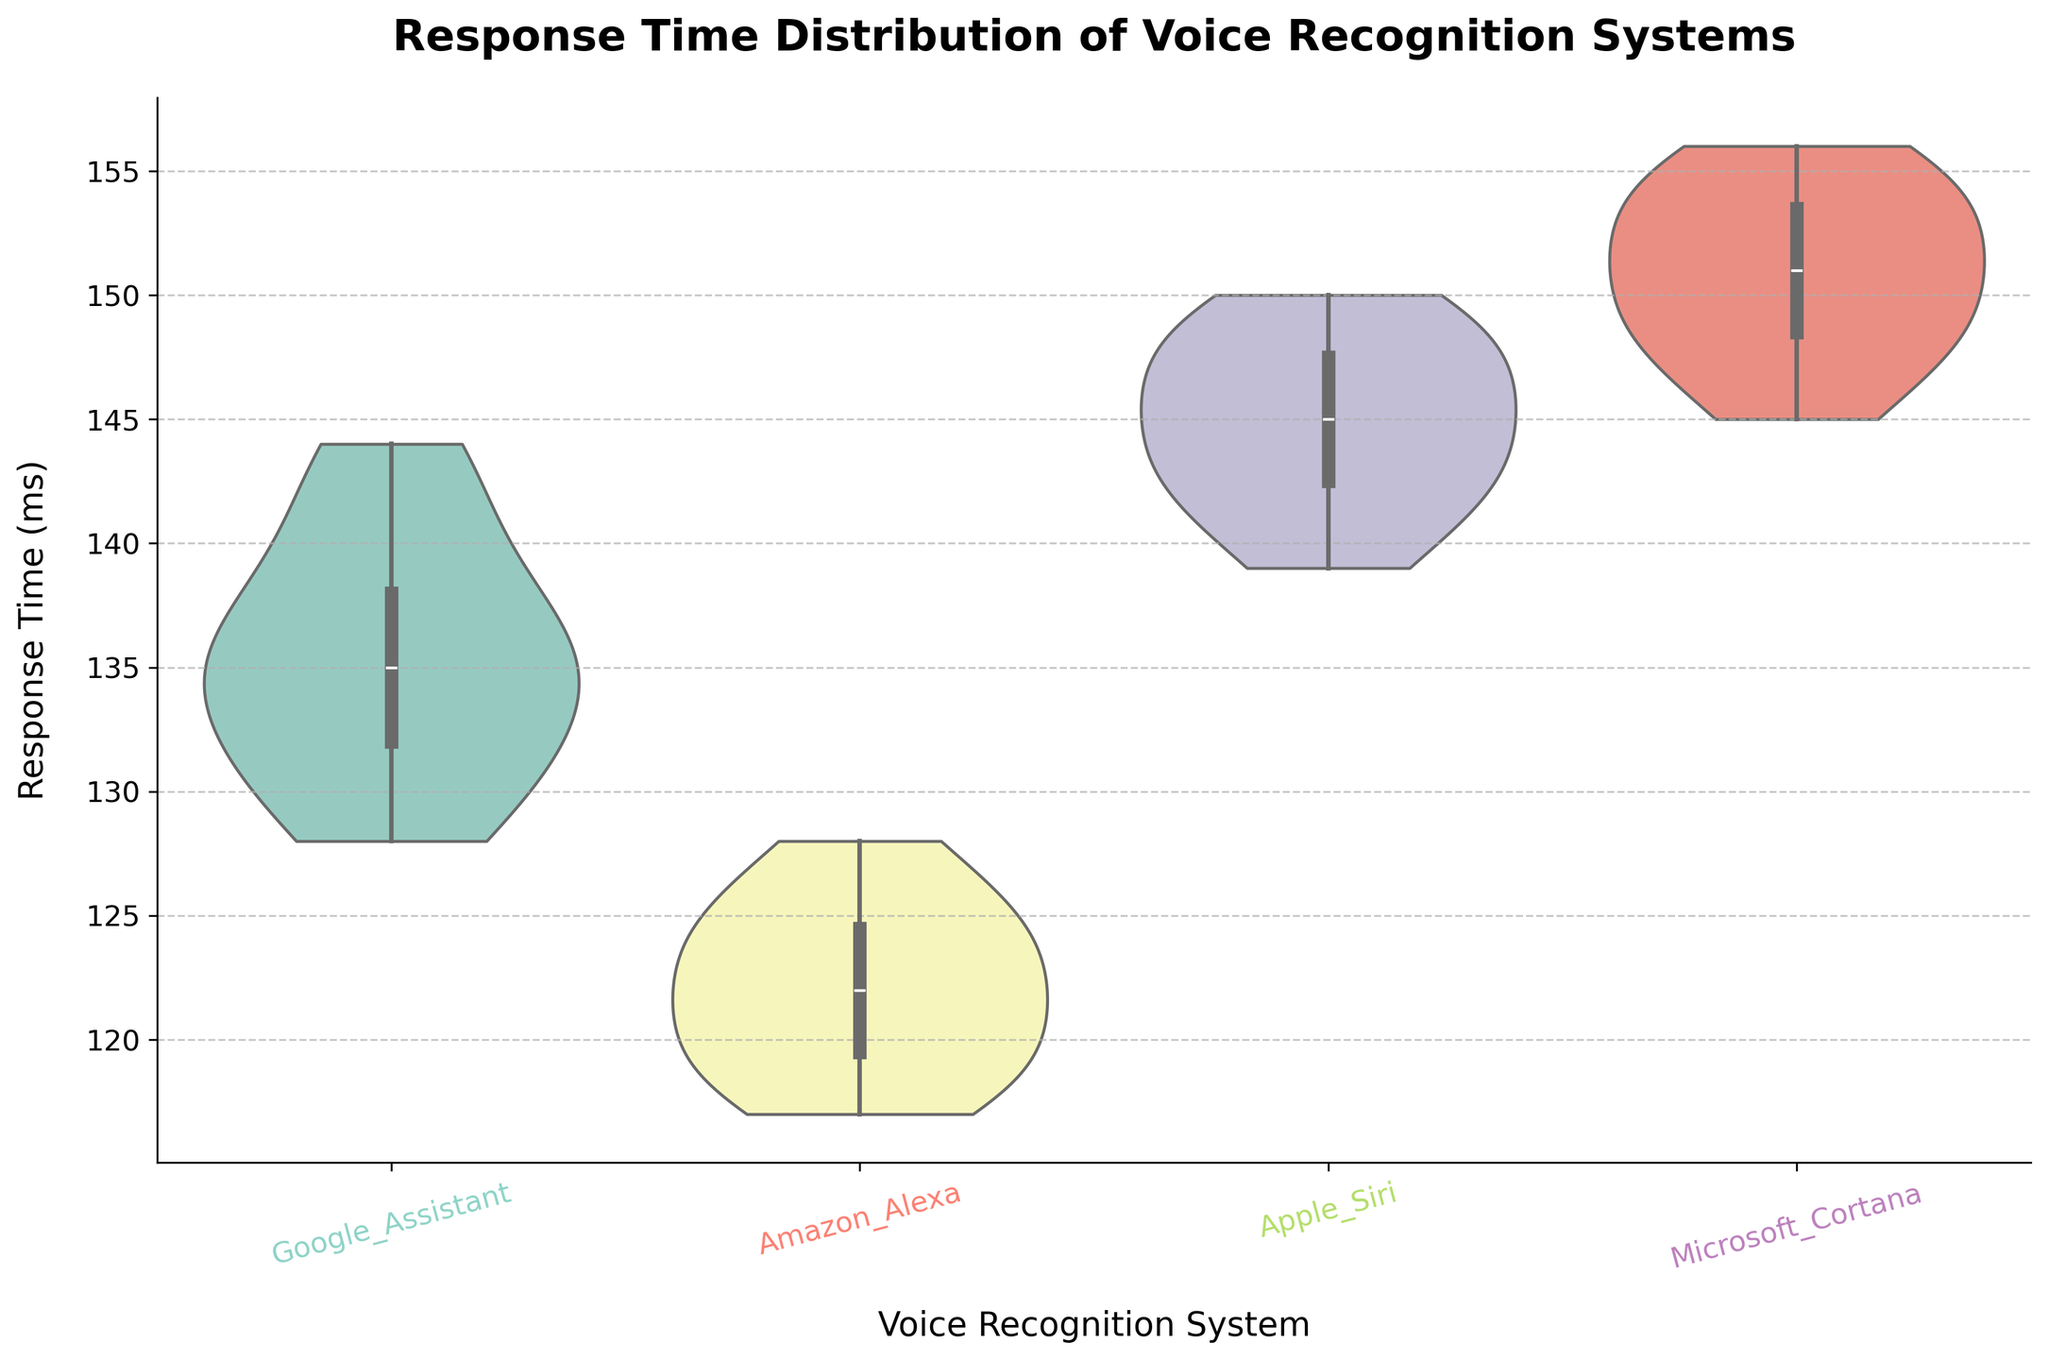What is the title of the figure? The title of the figure is usually at the top, describing the content of the chart. Here, it is "Response Time Distribution of Voice Recognition Systems".
Answer: Response Time Distribution of Voice Recognition Systems How many different voice recognition systems are compared in the chart? Count the unique categories on the x-axis, which correspond to different voice recognition systems.
Answer: 4 Which voice recognition system has the lowest median response time? Observe the horizontal line within each violin plot, which indicates the median value. The lowest median response time can be found by comparing these lines across all systems.
Answer: Amazon Alexa What is the approximate response time range for Google Assistant? Look at the spread of the violin plot for Google Assistant along the y-axis, which shows the range of response times.
Answer: Approximately 128-144 ms How does the median response time of Apple Siri compare to Microsoft Cortana? Check the horizontal lines within the Apple Siri and Microsoft Cortana violin plots, and compare their positions on the y-axis.
Answer: Apple Siri's median is lower than Microsoft Cortana's Which voice recognition system has the most variable response times? Observe the width and shape of the violin plots. A wider plot indicates more variability.
Answer: Microsoft Cortana What is the interquartile range (IQR) of response times for Amazon Alexa? Examine the box within the Amazon Alexa violin plot. The IQR is the range between the 25th and 75th percentiles.
Answer: Approximately 117-126 ms Are there any outliers in the response time distribution of Apple Siri? Look for any data points that fall outside the whiskers of the box within the Apple Siri plot.
Answer: No Which system has the highest response time recorded? Find the highest point reached in all the violin plots on the y-axis.
Answer: Microsoft Cortana Compare the spread (variability) of response times between Google Assistant and Apple Siri. Analyze the width and shape of the violin plots for both systems. A narrower plot indicates less variability, and a wider plot indicates more.
Answer: Google Assistant has less variability than Apple Siri 